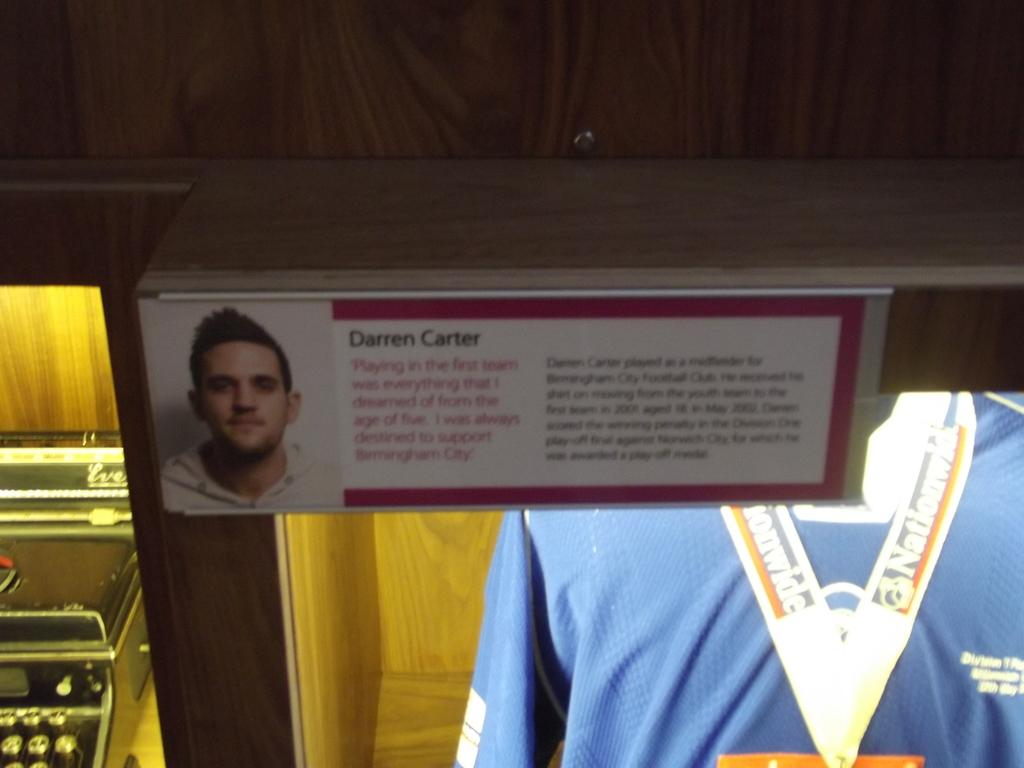<image>
Present a compact description of the photo's key features. A sign with information about Darren Carter is displayed above a blue shirt with a Nationwide banner on it. 